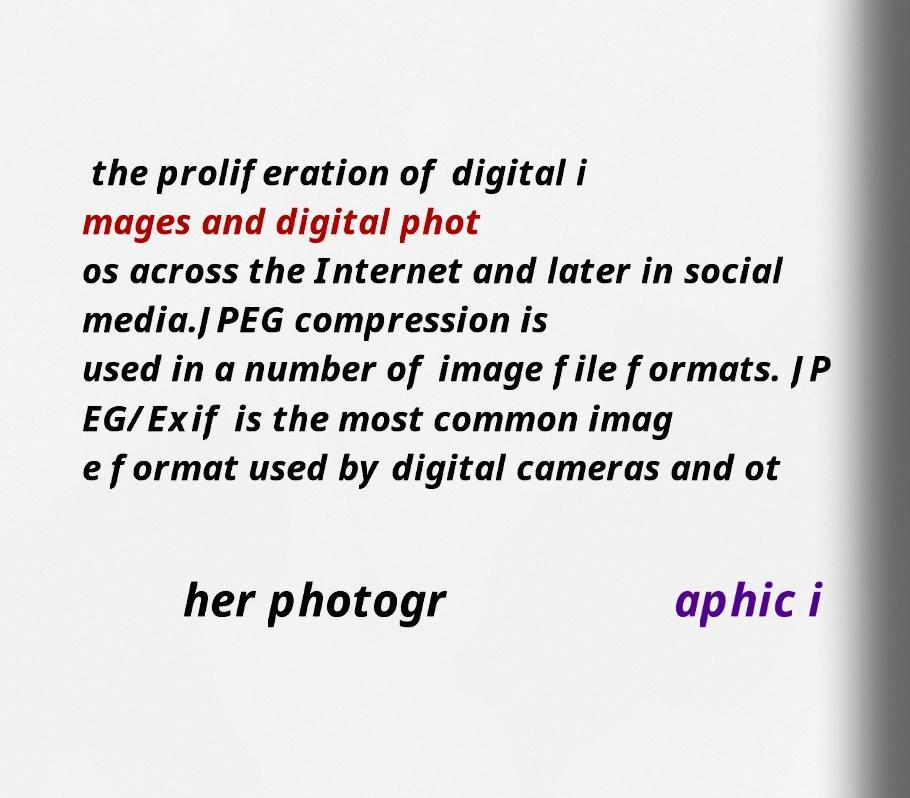Please read and relay the text visible in this image. What does it say? the proliferation of digital i mages and digital phot os across the Internet and later in social media.JPEG compression is used in a number of image file formats. JP EG/Exif is the most common imag e format used by digital cameras and ot her photogr aphic i 